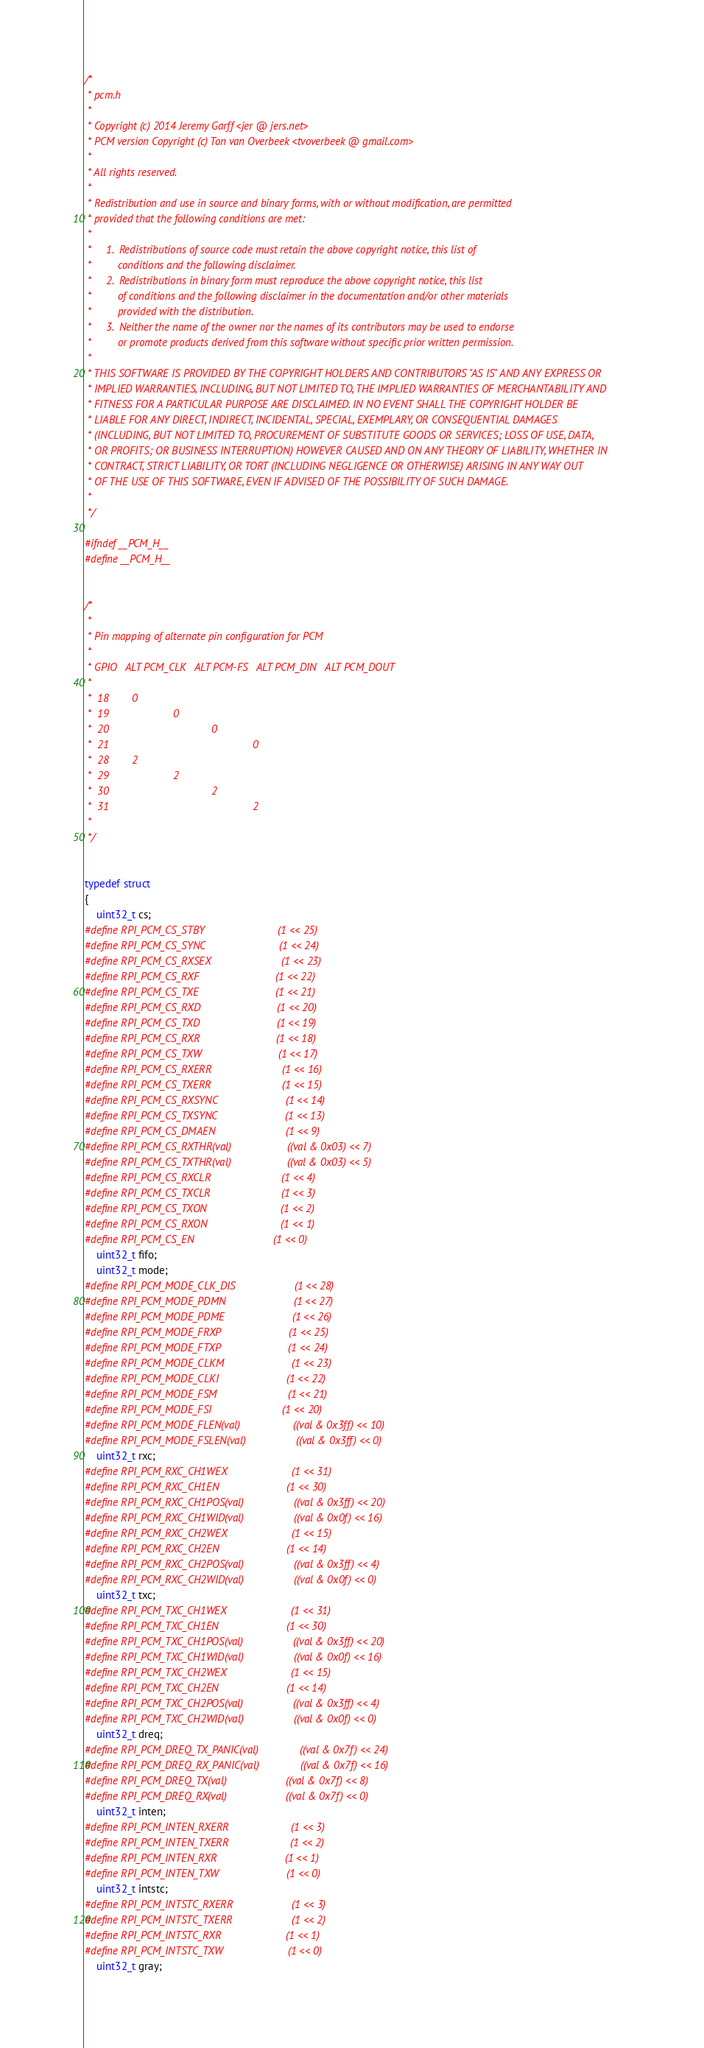<code> <loc_0><loc_0><loc_500><loc_500><_C_>/*
 * pcm.h
 *
 * Copyright (c) 2014 Jeremy Garff <jer @ jers.net>
 * PCM version Copyright (c) Ton van Overbeek <tvoverbeek @ gmail.com>
 *
 * All rights reserved.
 *
 * Redistribution and use in source and binary forms, with or without modification, are permitted
 * provided that the following conditions are met:
 *
 *     1.  Redistributions of source code must retain the above copyright notice, this list of
 *         conditions and the following disclaimer.
 *     2.  Redistributions in binary form must reproduce the above copyright notice, this list
 *         of conditions and the following disclaimer in the documentation and/or other materials
 *         provided with the distribution.
 *     3.  Neither the name of the owner nor the names of its contributors may be used to endorse
 *         or promote products derived from this software without specific prior written permission.
 * 
 * THIS SOFTWARE IS PROVIDED BY THE COPYRIGHT HOLDERS AND CONTRIBUTORS "AS IS" AND ANY EXPRESS OR
 * IMPLIED WARRANTIES, INCLUDING, BUT NOT LIMITED TO, THE IMPLIED WARRANTIES OF MERCHANTABILITY AND
 * FITNESS FOR A PARTICULAR PURPOSE ARE DISCLAIMED. IN NO EVENT SHALL THE COPYRIGHT HOLDER BE
 * LIABLE FOR ANY DIRECT, INDIRECT, INCIDENTAL, SPECIAL, EXEMPLARY, OR CONSEQUENTIAL DAMAGES
 * (INCLUDING, BUT NOT LIMITED TO, PROCUREMENT OF SUBSTITUTE GOODS OR SERVICES; LOSS OF USE, DATA,
 * OR PROFITS; OR BUSINESS INTERRUPTION) HOWEVER CAUSED AND ON ANY THEORY OF LIABILITY, WHETHER IN
 * CONTRACT, STRICT LIABILITY, OR TORT (INCLUDING NEGLIGENCE OR OTHERWISE) ARISING IN ANY WAY OUT
 * OF THE USE OF THIS SOFTWARE, EVEN IF ADVISED OF THE POSSIBILITY OF SUCH DAMAGE.
 *
 */

#ifndef __PCM_H__
#define __PCM_H__


/*
 *
 * Pin mapping of alternate pin configuration for PCM
 *
 * GPIO   ALT PCM_CLK   ALT PCM-FS   ALT PCM_DIN   ALT PCM_DOUT
 *
 *  18        0             
 *  19                      0
 *  20                                   0
 *  21                                                 0
 *  28        2 
 *  29                      2
 *  30                                   2
 *  31                                                 2
 *
 */


typedef struct
{
    uint32_t cs;
#define RPI_PCM_CS_STBY                         (1 << 25)
#define RPI_PCM_CS_SYNC                         (1 << 24)
#define RPI_PCM_CS_RXSEX                        (1 << 23)
#define RPI_PCM_CS_RXF                          (1 << 22)
#define RPI_PCM_CS_TXE                          (1 << 21)
#define RPI_PCM_CS_RXD                          (1 << 20)
#define RPI_PCM_CS_TXD                          (1 << 19)
#define RPI_PCM_CS_RXR                          (1 << 18)
#define RPI_PCM_CS_TXW                          (1 << 17)
#define RPI_PCM_CS_RXERR                        (1 << 16)
#define RPI_PCM_CS_TXERR                        (1 << 15)
#define RPI_PCM_CS_RXSYNC                       (1 << 14)
#define RPI_PCM_CS_TXSYNC                       (1 << 13)
#define RPI_PCM_CS_DMAEN                        (1 << 9)
#define RPI_PCM_CS_RXTHR(val)                   ((val & 0x03) << 7)
#define RPI_PCM_CS_TXTHR(val)                   ((val & 0x03) << 5)
#define RPI_PCM_CS_RXCLR                        (1 << 4)
#define RPI_PCM_CS_TXCLR                        (1 << 3)
#define RPI_PCM_CS_TXON                         (1 << 2)
#define RPI_PCM_CS_RXON                         (1 << 1)
#define RPI_PCM_CS_EN                           (1 << 0)
    uint32_t fifo;
    uint32_t mode;
#define RPI_PCM_MODE_CLK_DIS                    (1 << 28)
#define RPI_PCM_MODE_PDMN                       (1 << 27)
#define RPI_PCM_MODE_PDME                       (1 << 26)
#define RPI_PCM_MODE_FRXP                       (1 << 25)
#define RPI_PCM_MODE_FTXP                       (1 << 24)
#define RPI_PCM_MODE_CLKM                       (1 << 23)
#define RPI_PCM_MODE_CLKI                       (1 << 22)
#define RPI_PCM_MODE_FSM                        (1 << 21)
#define RPI_PCM_MODE_FSI                        (1 << 20)
#define RPI_PCM_MODE_FLEN(val)                  ((val & 0x3ff) << 10)
#define RPI_PCM_MODE_FSLEN(val)                 ((val & 0x3ff) << 0)
    uint32_t rxc;
#define RPI_PCM_RXC_CH1WEX                      (1 << 31)
#define RPI_PCM_RXC_CH1EN                       (1 << 30)
#define RPI_PCM_RXC_CH1POS(val)                 ((val & 0x3ff) << 20)
#define RPI_PCM_RXC_CH1WID(val)                 ((val & 0x0f) << 16)
#define RPI_PCM_RXC_CH2WEX                      (1 << 15)
#define RPI_PCM_RXC_CH2EN                       (1 << 14)
#define RPI_PCM_RXC_CH2POS(val)                 ((val & 0x3ff) << 4)
#define RPI_PCM_RXC_CH2WID(val)                 ((val & 0x0f) << 0)
    uint32_t txc;
#define RPI_PCM_TXC_CH1WEX                      (1 << 31)
#define RPI_PCM_TXC_CH1EN                       (1 << 30)
#define RPI_PCM_TXC_CH1POS(val)                 ((val & 0x3ff) << 20)
#define RPI_PCM_TXC_CH1WID(val)                 ((val & 0x0f) << 16)
#define RPI_PCM_TXC_CH2WEX                      (1 << 15)
#define RPI_PCM_TXC_CH2EN                       (1 << 14)
#define RPI_PCM_TXC_CH2POS(val)                 ((val & 0x3ff) << 4)
#define RPI_PCM_TXC_CH2WID(val)                 ((val & 0x0f) << 0)
    uint32_t dreq;
#define RPI_PCM_DREQ_TX_PANIC(val)              ((val & 0x7f) << 24)
#define RPI_PCM_DREQ_RX_PANIC(val)              ((val & 0x7f) << 16)
#define RPI_PCM_DREQ_TX(val)                    ((val & 0x7f) << 8)
#define RPI_PCM_DREQ_RX(val)                    ((val & 0x7f) << 0)
    uint32_t inten;
#define RPI_PCM_INTEN_RXERR                     (1 << 3)
#define RPI_PCM_INTEN_TXERR                     (1 << 2)
#define RPI_PCM_INTEN_RXR                       (1 << 1)
#define RPI_PCM_INTEN_TXW                       (1 << 0)
    uint32_t intstc;
#define RPI_PCM_INTSTC_RXERR                    (1 << 3)
#define RPI_PCM_INTSTC_TXERR                    (1 << 2)
#define RPI_PCM_INTSTC_RXR                      (1 << 1)
#define RPI_PCM_INTSTC_TXW                      (1 << 0)
    uint32_t gray;</code> 